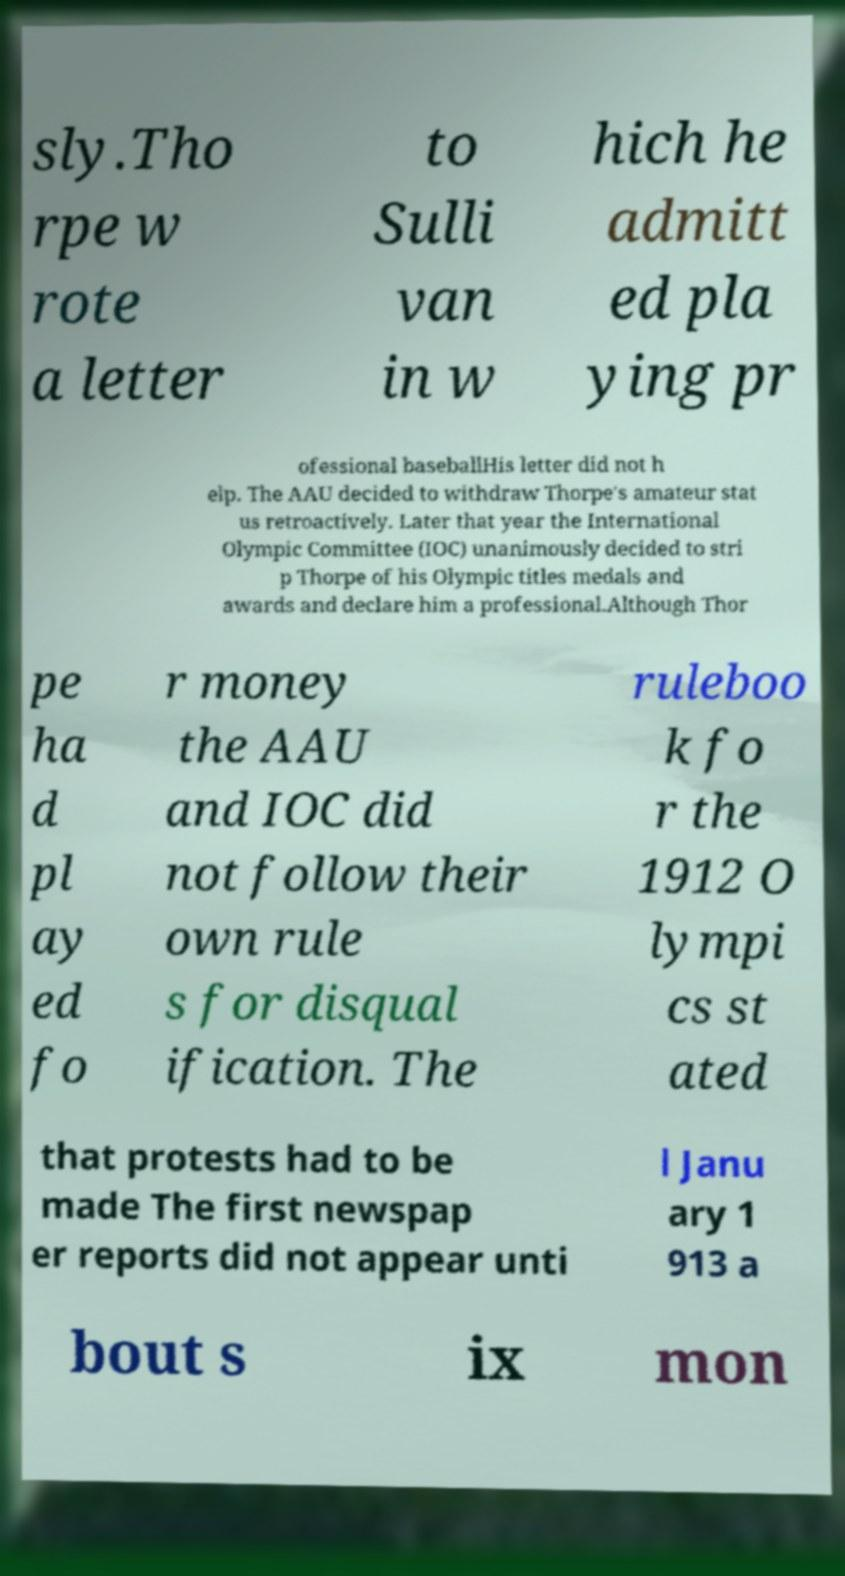Could you assist in decoding the text presented in this image and type it out clearly? sly.Tho rpe w rote a letter to Sulli van in w hich he admitt ed pla ying pr ofessional baseballHis letter did not h elp. The AAU decided to withdraw Thorpe's amateur stat us retroactively. Later that year the International Olympic Committee (IOC) unanimously decided to stri p Thorpe of his Olympic titles medals and awards and declare him a professional.Although Thor pe ha d pl ay ed fo r money the AAU and IOC did not follow their own rule s for disqual ification. The ruleboo k fo r the 1912 O lympi cs st ated that protests had to be made The first newspap er reports did not appear unti l Janu ary 1 913 a bout s ix mon 